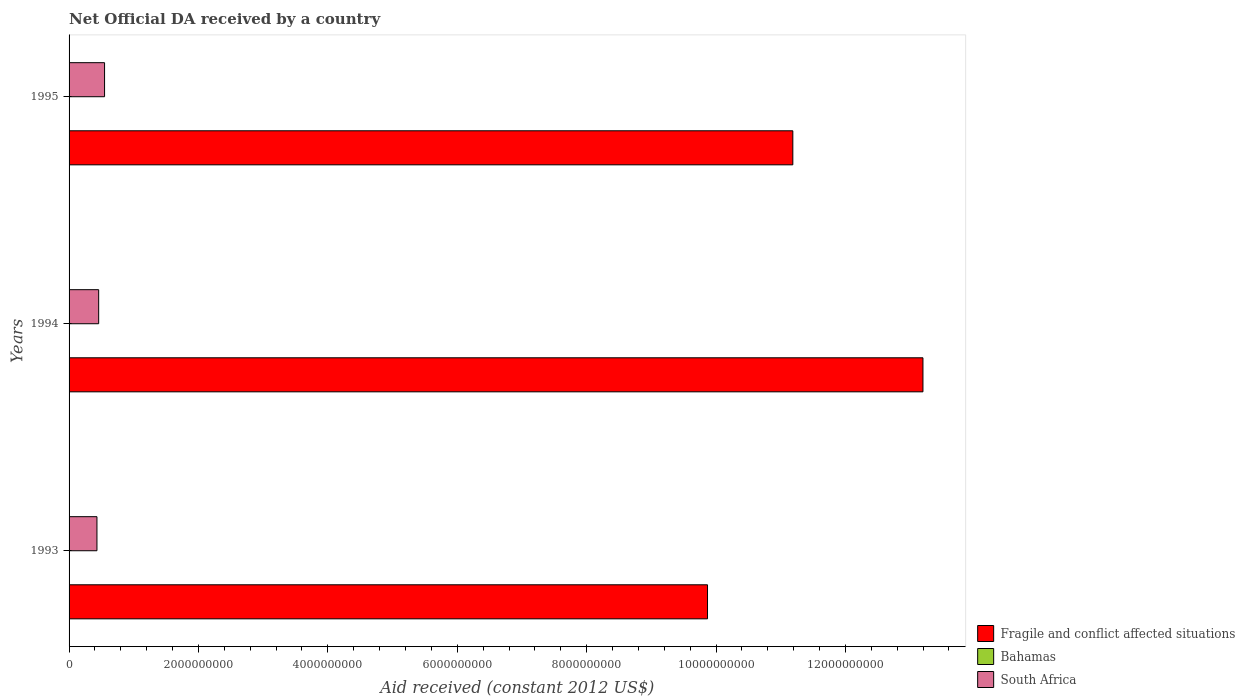How many different coloured bars are there?
Offer a terse response. 3. How many bars are there on the 2nd tick from the bottom?
Your answer should be compact. 3. What is the label of the 1st group of bars from the top?
Your answer should be compact. 1995. In how many cases, is the number of bars for a given year not equal to the number of legend labels?
Offer a terse response. 0. What is the net official development assistance aid received in Bahamas in 1994?
Offer a very short reply. 1.26e+06. Across all years, what is the maximum net official development assistance aid received in South Africa?
Your response must be concise. 5.49e+08. Across all years, what is the minimum net official development assistance aid received in South Africa?
Provide a short and direct response. 4.31e+08. In which year was the net official development assistance aid received in Bahamas minimum?
Make the answer very short. 1994. What is the total net official development assistance aid received in South Africa in the graph?
Offer a terse response. 1.44e+09. What is the difference between the net official development assistance aid received in Fragile and conflict affected situations in 1994 and that in 1995?
Your answer should be very brief. 2.01e+09. What is the difference between the net official development assistance aid received in South Africa in 1993 and the net official development assistance aid received in Fragile and conflict affected situations in 1994?
Provide a short and direct response. -1.28e+1. What is the average net official development assistance aid received in Fragile and conflict affected situations per year?
Provide a succinct answer. 1.14e+1. In the year 1995, what is the difference between the net official development assistance aid received in South Africa and net official development assistance aid received in Fragile and conflict affected situations?
Provide a short and direct response. -1.06e+1. What is the ratio of the net official development assistance aid received in Bahamas in 1994 to that in 1995?
Offer a terse response. 0.22. Is the net official development assistance aid received in Bahamas in 1993 less than that in 1995?
Make the answer very short. Yes. Is the difference between the net official development assistance aid received in South Africa in 1993 and 1995 greater than the difference between the net official development assistance aid received in Fragile and conflict affected situations in 1993 and 1995?
Make the answer very short. Yes. What is the difference between the highest and the second highest net official development assistance aid received in Bahamas?
Give a very brief answer. 4.11e+06. What is the difference between the highest and the lowest net official development assistance aid received in South Africa?
Your response must be concise. 1.18e+08. Is the sum of the net official development assistance aid received in South Africa in 1993 and 1994 greater than the maximum net official development assistance aid received in Fragile and conflict affected situations across all years?
Provide a succinct answer. No. What does the 1st bar from the top in 1993 represents?
Make the answer very short. South Africa. What does the 2nd bar from the bottom in 1995 represents?
Provide a succinct answer. Bahamas. Is it the case that in every year, the sum of the net official development assistance aid received in Bahamas and net official development assistance aid received in Fragile and conflict affected situations is greater than the net official development assistance aid received in South Africa?
Your response must be concise. Yes. Are all the bars in the graph horizontal?
Your answer should be compact. Yes. Are the values on the major ticks of X-axis written in scientific E-notation?
Your response must be concise. No. Does the graph contain any zero values?
Keep it short and to the point. No. Does the graph contain grids?
Offer a very short reply. No. How are the legend labels stacked?
Your answer should be very brief. Vertical. What is the title of the graph?
Offer a very short reply. Net Official DA received by a country. What is the label or title of the X-axis?
Provide a short and direct response. Aid received (constant 2012 US$). What is the Aid received (constant 2012 US$) in Fragile and conflict affected situations in 1993?
Make the answer very short. 9.87e+09. What is the Aid received (constant 2012 US$) in Bahamas in 1993?
Offer a very short reply. 1.56e+06. What is the Aid received (constant 2012 US$) of South Africa in 1993?
Your answer should be compact. 4.31e+08. What is the Aid received (constant 2012 US$) in Fragile and conflict affected situations in 1994?
Your response must be concise. 1.32e+1. What is the Aid received (constant 2012 US$) in Bahamas in 1994?
Offer a terse response. 1.26e+06. What is the Aid received (constant 2012 US$) in South Africa in 1994?
Your answer should be very brief. 4.58e+08. What is the Aid received (constant 2012 US$) in Fragile and conflict affected situations in 1995?
Offer a terse response. 1.12e+1. What is the Aid received (constant 2012 US$) in Bahamas in 1995?
Your answer should be very brief. 5.67e+06. What is the Aid received (constant 2012 US$) of South Africa in 1995?
Your answer should be very brief. 5.49e+08. Across all years, what is the maximum Aid received (constant 2012 US$) in Fragile and conflict affected situations?
Ensure brevity in your answer.  1.32e+1. Across all years, what is the maximum Aid received (constant 2012 US$) of Bahamas?
Your answer should be very brief. 5.67e+06. Across all years, what is the maximum Aid received (constant 2012 US$) of South Africa?
Your answer should be very brief. 5.49e+08. Across all years, what is the minimum Aid received (constant 2012 US$) of Fragile and conflict affected situations?
Your response must be concise. 9.87e+09. Across all years, what is the minimum Aid received (constant 2012 US$) in Bahamas?
Make the answer very short. 1.26e+06. Across all years, what is the minimum Aid received (constant 2012 US$) in South Africa?
Offer a very short reply. 4.31e+08. What is the total Aid received (constant 2012 US$) in Fragile and conflict affected situations in the graph?
Keep it short and to the point. 3.43e+1. What is the total Aid received (constant 2012 US$) in Bahamas in the graph?
Ensure brevity in your answer.  8.49e+06. What is the total Aid received (constant 2012 US$) of South Africa in the graph?
Provide a short and direct response. 1.44e+09. What is the difference between the Aid received (constant 2012 US$) in Fragile and conflict affected situations in 1993 and that in 1994?
Offer a very short reply. -3.33e+09. What is the difference between the Aid received (constant 2012 US$) of South Africa in 1993 and that in 1994?
Offer a terse response. -2.67e+07. What is the difference between the Aid received (constant 2012 US$) of Fragile and conflict affected situations in 1993 and that in 1995?
Keep it short and to the point. -1.32e+09. What is the difference between the Aid received (constant 2012 US$) of Bahamas in 1993 and that in 1995?
Ensure brevity in your answer.  -4.11e+06. What is the difference between the Aid received (constant 2012 US$) in South Africa in 1993 and that in 1995?
Offer a very short reply. -1.18e+08. What is the difference between the Aid received (constant 2012 US$) of Fragile and conflict affected situations in 1994 and that in 1995?
Your answer should be very brief. 2.01e+09. What is the difference between the Aid received (constant 2012 US$) of Bahamas in 1994 and that in 1995?
Your answer should be very brief. -4.41e+06. What is the difference between the Aid received (constant 2012 US$) of South Africa in 1994 and that in 1995?
Offer a very short reply. -9.11e+07. What is the difference between the Aid received (constant 2012 US$) of Fragile and conflict affected situations in 1993 and the Aid received (constant 2012 US$) of Bahamas in 1994?
Offer a terse response. 9.87e+09. What is the difference between the Aid received (constant 2012 US$) in Fragile and conflict affected situations in 1993 and the Aid received (constant 2012 US$) in South Africa in 1994?
Keep it short and to the point. 9.41e+09. What is the difference between the Aid received (constant 2012 US$) of Bahamas in 1993 and the Aid received (constant 2012 US$) of South Africa in 1994?
Give a very brief answer. -4.56e+08. What is the difference between the Aid received (constant 2012 US$) in Fragile and conflict affected situations in 1993 and the Aid received (constant 2012 US$) in Bahamas in 1995?
Your answer should be very brief. 9.86e+09. What is the difference between the Aid received (constant 2012 US$) of Fragile and conflict affected situations in 1993 and the Aid received (constant 2012 US$) of South Africa in 1995?
Provide a short and direct response. 9.32e+09. What is the difference between the Aid received (constant 2012 US$) of Bahamas in 1993 and the Aid received (constant 2012 US$) of South Africa in 1995?
Offer a very short reply. -5.47e+08. What is the difference between the Aid received (constant 2012 US$) of Fragile and conflict affected situations in 1994 and the Aid received (constant 2012 US$) of Bahamas in 1995?
Give a very brief answer. 1.32e+1. What is the difference between the Aid received (constant 2012 US$) in Fragile and conflict affected situations in 1994 and the Aid received (constant 2012 US$) in South Africa in 1995?
Offer a terse response. 1.26e+1. What is the difference between the Aid received (constant 2012 US$) in Bahamas in 1994 and the Aid received (constant 2012 US$) in South Africa in 1995?
Offer a terse response. -5.47e+08. What is the average Aid received (constant 2012 US$) in Fragile and conflict affected situations per year?
Your answer should be compact. 1.14e+1. What is the average Aid received (constant 2012 US$) in Bahamas per year?
Provide a short and direct response. 2.83e+06. What is the average Aid received (constant 2012 US$) of South Africa per year?
Ensure brevity in your answer.  4.79e+08. In the year 1993, what is the difference between the Aid received (constant 2012 US$) in Fragile and conflict affected situations and Aid received (constant 2012 US$) in Bahamas?
Offer a very short reply. 9.87e+09. In the year 1993, what is the difference between the Aid received (constant 2012 US$) in Fragile and conflict affected situations and Aid received (constant 2012 US$) in South Africa?
Make the answer very short. 9.44e+09. In the year 1993, what is the difference between the Aid received (constant 2012 US$) in Bahamas and Aid received (constant 2012 US$) in South Africa?
Your answer should be compact. -4.29e+08. In the year 1994, what is the difference between the Aid received (constant 2012 US$) in Fragile and conflict affected situations and Aid received (constant 2012 US$) in Bahamas?
Provide a short and direct response. 1.32e+1. In the year 1994, what is the difference between the Aid received (constant 2012 US$) of Fragile and conflict affected situations and Aid received (constant 2012 US$) of South Africa?
Provide a short and direct response. 1.27e+1. In the year 1994, what is the difference between the Aid received (constant 2012 US$) of Bahamas and Aid received (constant 2012 US$) of South Africa?
Provide a short and direct response. -4.56e+08. In the year 1995, what is the difference between the Aid received (constant 2012 US$) of Fragile and conflict affected situations and Aid received (constant 2012 US$) of Bahamas?
Offer a terse response. 1.12e+1. In the year 1995, what is the difference between the Aid received (constant 2012 US$) of Fragile and conflict affected situations and Aid received (constant 2012 US$) of South Africa?
Your response must be concise. 1.06e+1. In the year 1995, what is the difference between the Aid received (constant 2012 US$) of Bahamas and Aid received (constant 2012 US$) of South Africa?
Your answer should be very brief. -5.43e+08. What is the ratio of the Aid received (constant 2012 US$) in Fragile and conflict affected situations in 1993 to that in 1994?
Give a very brief answer. 0.75. What is the ratio of the Aid received (constant 2012 US$) in Bahamas in 1993 to that in 1994?
Your answer should be compact. 1.24. What is the ratio of the Aid received (constant 2012 US$) of South Africa in 1993 to that in 1994?
Your response must be concise. 0.94. What is the ratio of the Aid received (constant 2012 US$) of Fragile and conflict affected situations in 1993 to that in 1995?
Your response must be concise. 0.88. What is the ratio of the Aid received (constant 2012 US$) of Bahamas in 1993 to that in 1995?
Make the answer very short. 0.28. What is the ratio of the Aid received (constant 2012 US$) in South Africa in 1993 to that in 1995?
Your answer should be compact. 0.79. What is the ratio of the Aid received (constant 2012 US$) of Fragile and conflict affected situations in 1994 to that in 1995?
Ensure brevity in your answer.  1.18. What is the ratio of the Aid received (constant 2012 US$) in Bahamas in 1994 to that in 1995?
Make the answer very short. 0.22. What is the ratio of the Aid received (constant 2012 US$) of South Africa in 1994 to that in 1995?
Give a very brief answer. 0.83. What is the difference between the highest and the second highest Aid received (constant 2012 US$) in Fragile and conflict affected situations?
Make the answer very short. 2.01e+09. What is the difference between the highest and the second highest Aid received (constant 2012 US$) in Bahamas?
Give a very brief answer. 4.11e+06. What is the difference between the highest and the second highest Aid received (constant 2012 US$) of South Africa?
Your response must be concise. 9.11e+07. What is the difference between the highest and the lowest Aid received (constant 2012 US$) in Fragile and conflict affected situations?
Give a very brief answer. 3.33e+09. What is the difference between the highest and the lowest Aid received (constant 2012 US$) of Bahamas?
Offer a terse response. 4.41e+06. What is the difference between the highest and the lowest Aid received (constant 2012 US$) in South Africa?
Give a very brief answer. 1.18e+08. 